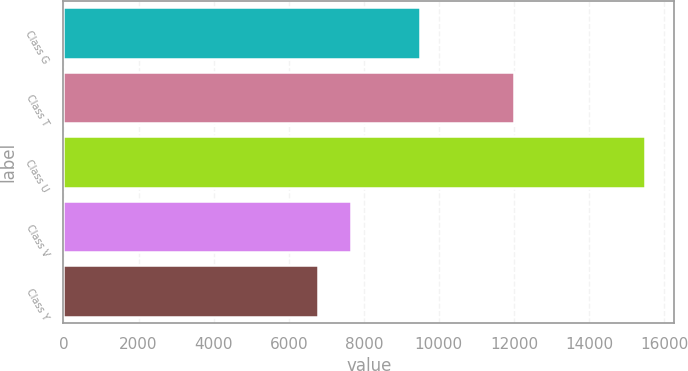<chart> <loc_0><loc_0><loc_500><loc_500><bar_chart><fcel>Class G<fcel>Class T<fcel>Class U<fcel>Class V<fcel>Class Y<nl><fcel>9492<fcel>12000<fcel>15500<fcel>7662.8<fcel>6792<nl></chart> 